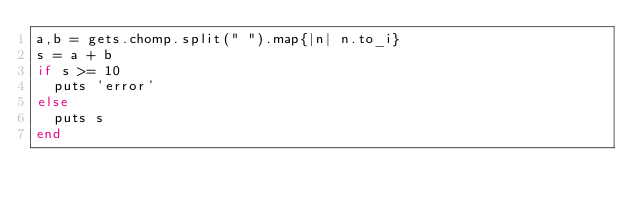<code> <loc_0><loc_0><loc_500><loc_500><_Ruby_>a,b = gets.chomp.split(" ").map{|n| n.to_i}
s = a + b
if s >= 10
	puts 'error'
else
	puts s
end</code> 